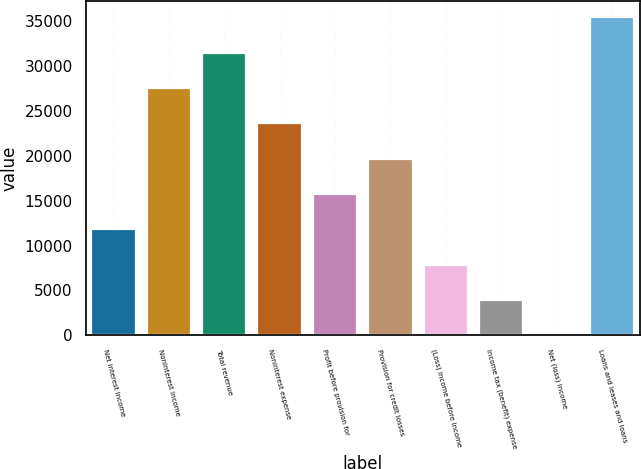<chart> <loc_0><loc_0><loc_500><loc_500><bar_chart><fcel>Net interest income<fcel>Noninterest income<fcel>Total revenue<fcel>Noninterest expense<fcel>Profit before provision for<fcel>Provision for credit losses<fcel>(Loss) income before income<fcel>Income tax (benefit) expense<fcel>Net (loss) income<fcel>Loans and leases and loans<nl><fcel>11827.3<fcel>27595.7<fcel>31537.8<fcel>23653.6<fcel>15769.4<fcel>19711.5<fcel>7885.2<fcel>3943.1<fcel>1<fcel>35479.9<nl></chart> 